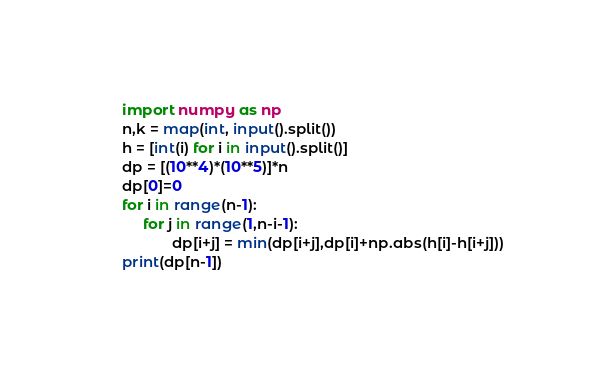Convert code to text. <code><loc_0><loc_0><loc_500><loc_500><_Python_>import numpy as np
n,k = map(int, input().split())
h = [int(i) for i in input().split()]
dp = [(10**4)*(10**5)]*n
dp[0]=0
for i in range(n-1):
     for j in range(1,n-i-1):
            dp[i+j] = min(dp[i+j],dp[i]+np.abs(h[i]-h[i+j]))
print(dp[n-1])   </code> 